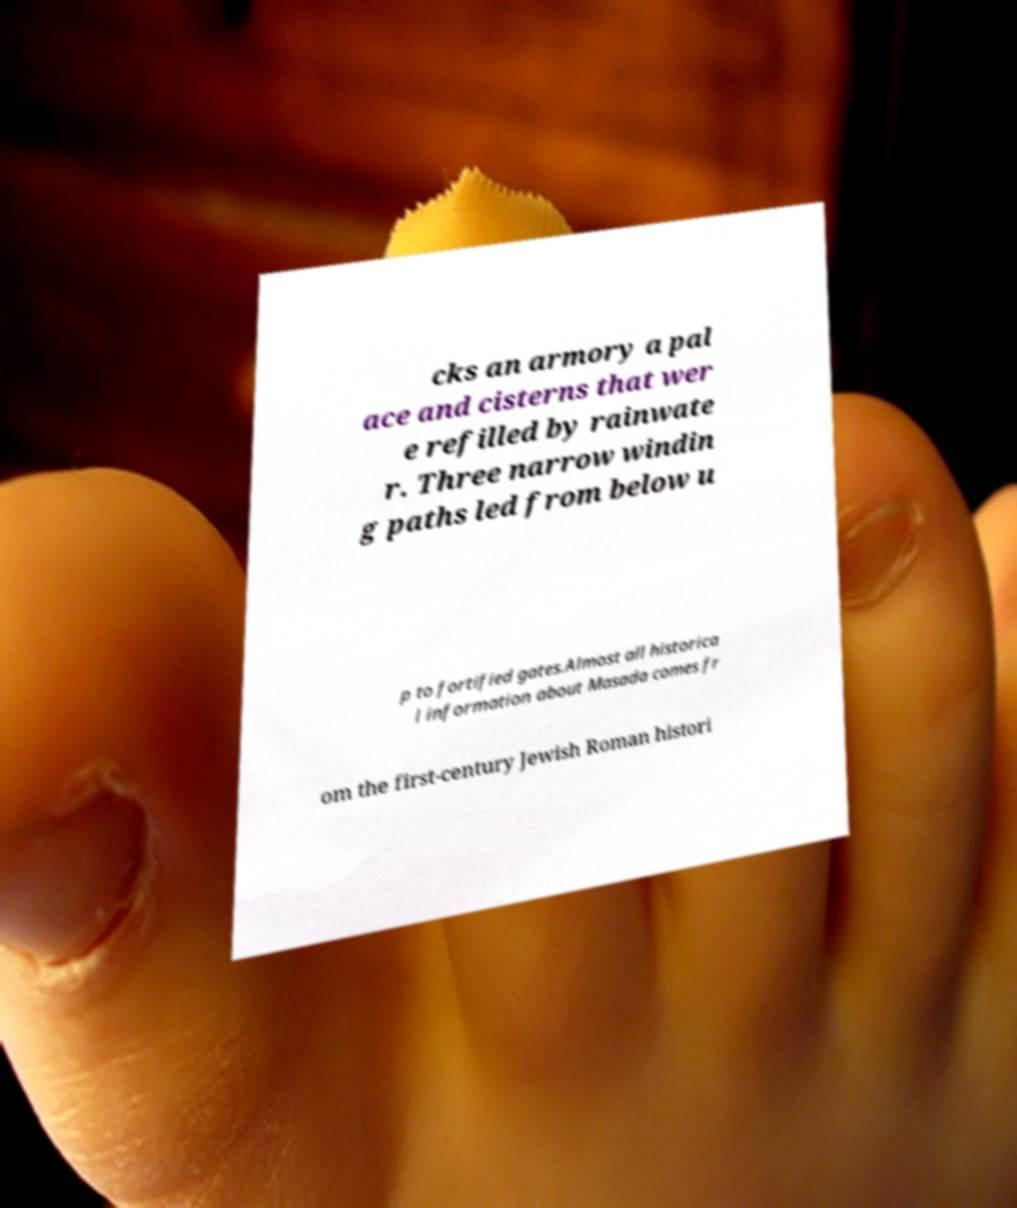Please read and relay the text visible in this image. What does it say? cks an armory a pal ace and cisterns that wer e refilled by rainwate r. Three narrow windin g paths led from below u p to fortified gates.Almost all historica l information about Masada comes fr om the first-century Jewish Roman histori 